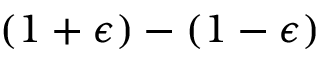Convert formula to latex. <formula><loc_0><loc_0><loc_500><loc_500>( 1 + \epsilon ) - ( 1 - \epsilon )</formula> 